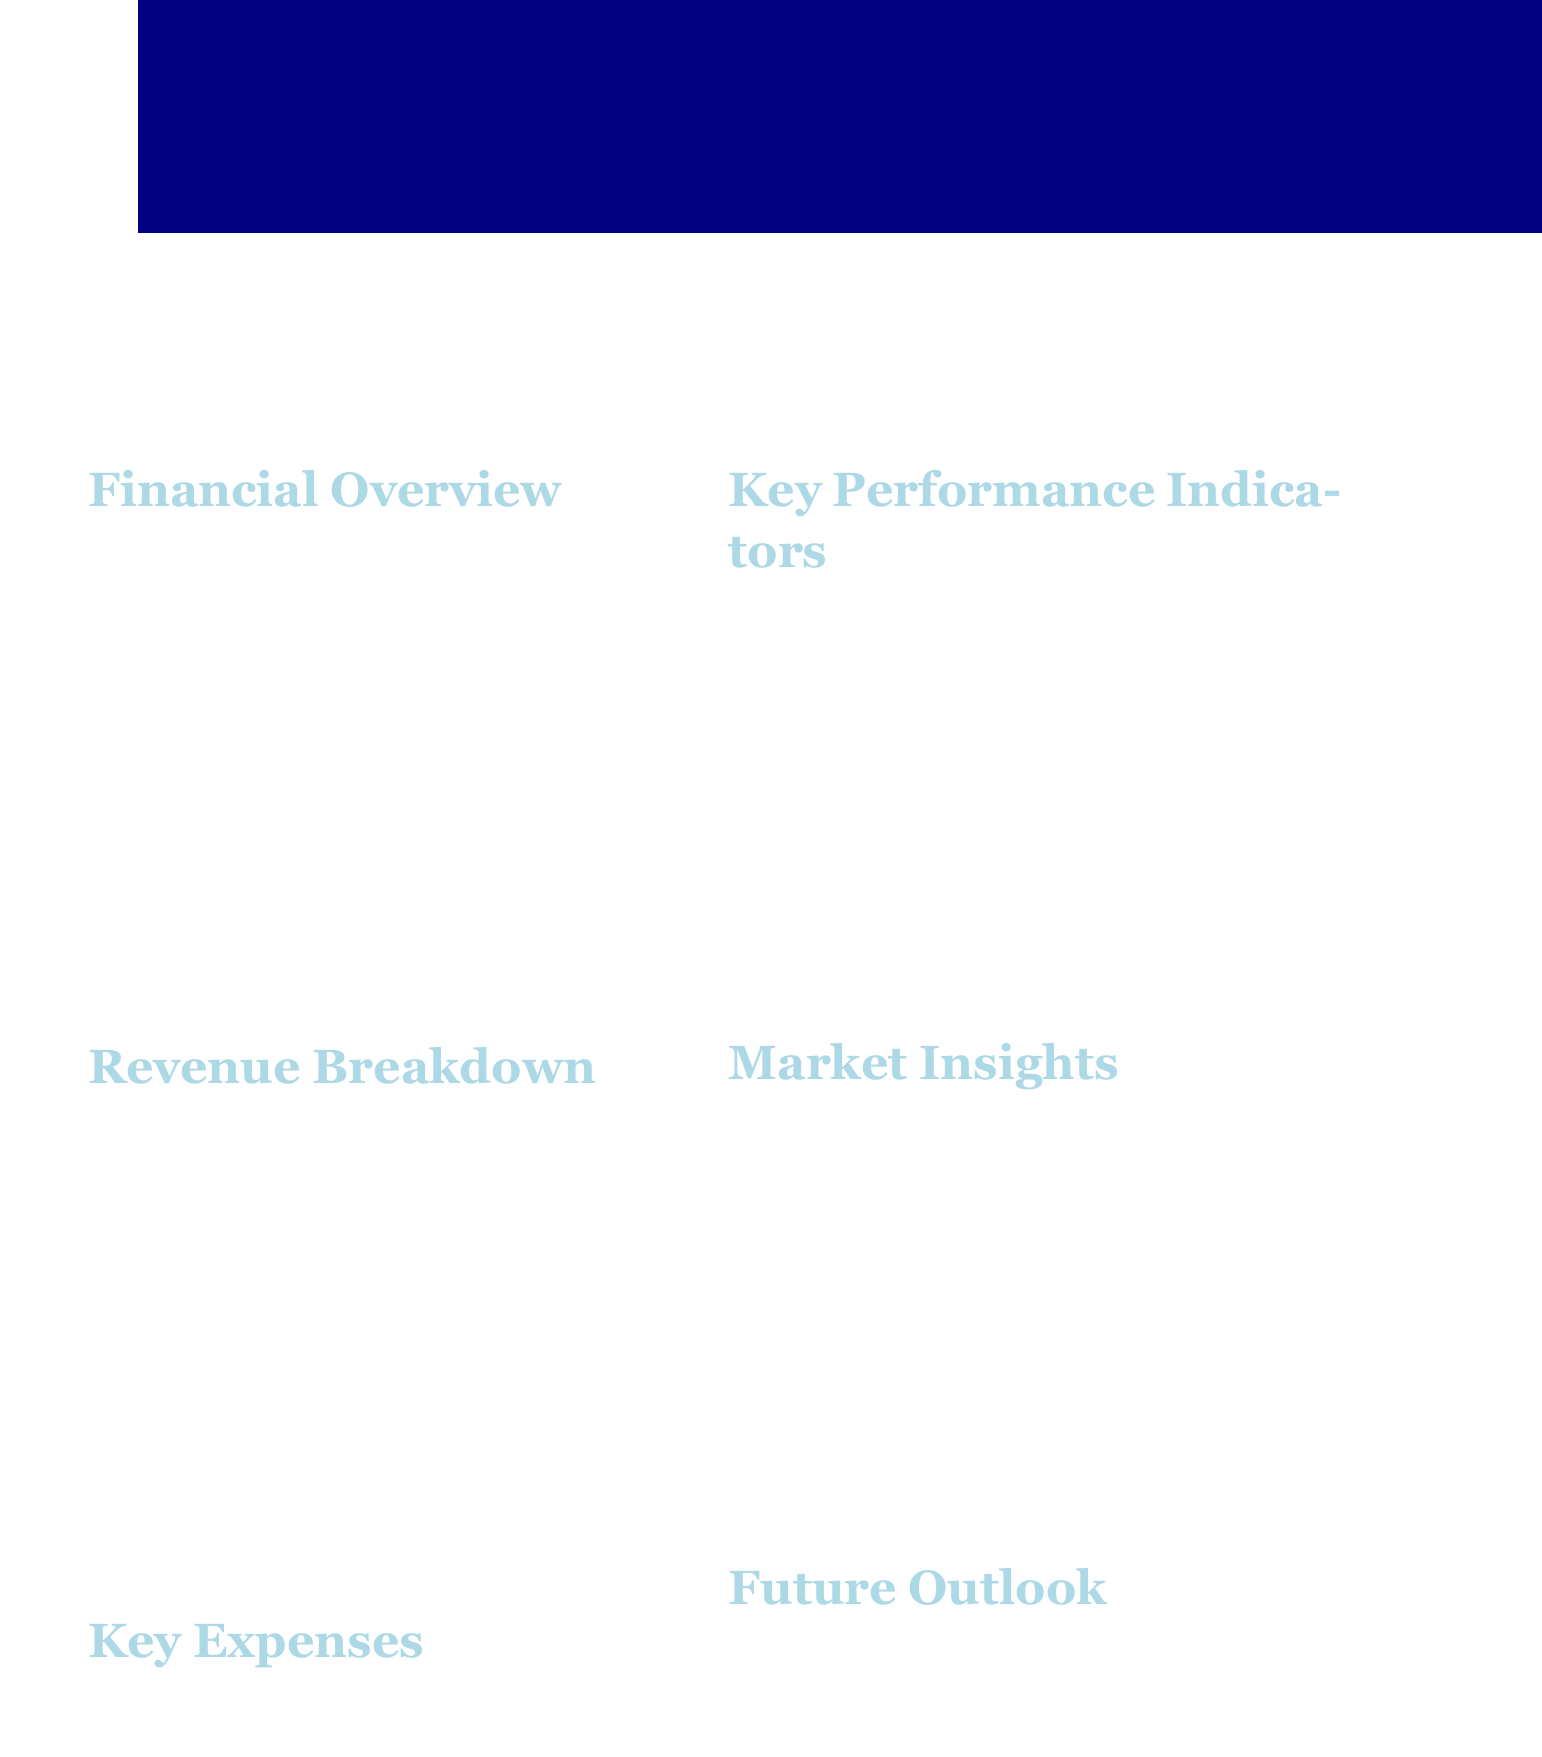What is the total revenue? The total revenue is listed in the financial overview section, which is $3,920,000.
Answer: $3,920,000 What is the bestselling title? The bestselling title is mentioned in the key performance indicators, which is "Magellan's Wake: The Legacy of Circumnavigation."
Answer: Magellan's Wake: The Legacy of Circumnavigation What was the net profit reported? The net profit is found in the financial overview section, which states a net profit of $1,125,000.
Answer: $1,125,000 What percentage increase in digital sales is noted? The market insights section specifies an 18% increase in digital sales from the previous quarter.
Answer: 18% How many new releases were there this quarter? The number of new releases is indicated in the key performance indicators as 7.
Answer: 7 What are the planned investments mentioned? The future outlook section notes planned investments in a new maritime history podcast series.
Answer: New maritime history podcast series What were the total expenses for the quarter? The total expenses are listed in the financial overview, amounting to $2,795,000.
Answer: $2,795,000 What is the expected revenue growth for Q4 2023? The future outlook specifies an expected revenue growth of 7% for Q4 2023.
Answer: 7% What is the top selling category according to market insights? The market insights section identifies the top selling category as Age of Discovery biographies.
Answer: Age of Discovery biographies 